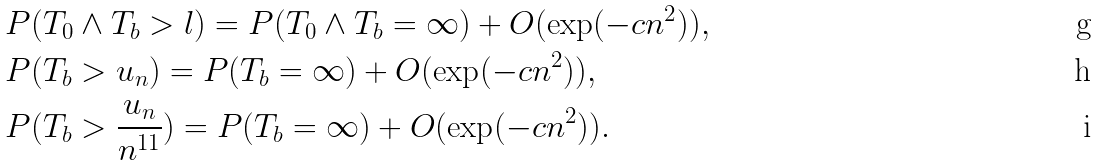Convert formula to latex. <formula><loc_0><loc_0><loc_500><loc_500>& P ( T _ { 0 } \wedge T _ { b } > l ) = P ( T _ { 0 } \wedge T _ { b } = \infty ) + O ( \exp ( - c n ^ { 2 } ) ) , \\ & P ( T _ { b } > u _ { n } ) = P ( T _ { b } = \infty ) + O ( \exp ( - c n ^ { 2 } ) ) , \\ & P ( T _ { b } > \frac { u _ { n } } { n ^ { 1 1 } } ) = P ( T _ { b } = \infty ) + O ( \exp ( - c n ^ { 2 } ) ) .</formula> 